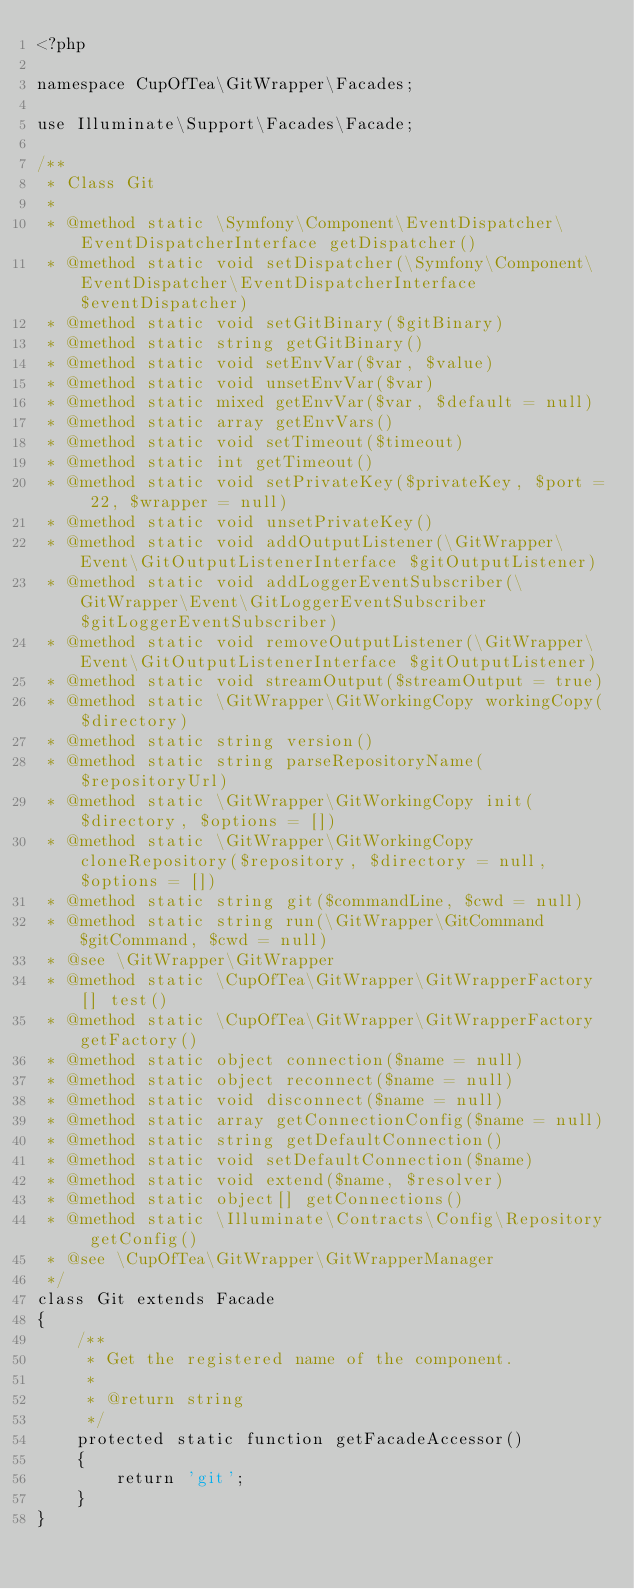Convert code to text. <code><loc_0><loc_0><loc_500><loc_500><_PHP_><?php

namespace CupOfTea\GitWrapper\Facades;

use Illuminate\Support\Facades\Facade;

/**
 * Class Git
 *
 * @method static \Symfony\Component\EventDispatcher\EventDispatcherInterface getDispatcher()
 * @method static void setDispatcher(\Symfony\Component\EventDispatcher\EventDispatcherInterface $eventDispatcher)
 * @method static void setGitBinary($gitBinary)
 * @method static string getGitBinary()
 * @method static void setEnvVar($var, $value)
 * @method static void unsetEnvVar($var)
 * @method static mixed getEnvVar($var, $default = null)
 * @method static array getEnvVars()
 * @method static void setTimeout($timeout)
 * @method static int getTimeout()
 * @method static void setPrivateKey($privateKey, $port = 22, $wrapper = null)
 * @method static void unsetPrivateKey()
 * @method static void addOutputListener(\GitWrapper\Event\GitOutputListenerInterface $gitOutputListener)
 * @method static void addLoggerEventSubscriber(\GitWrapper\Event\GitLoggerEventSubscriber $gitLoggerEventSubscriber)
 * @method static void removeOutputListener(\GitWrapper\Event\GitOutputListenerInterface $gitOutputListener)
 * @method static void streamOutput($streamOutput = true)
 * @method static \GitWrapper\GitWorkingCopy workingCopy($directory)
 * @method static string version()
 * @method static string parseRepositoryName($repositoryUrl)
 * @method static \GitWrapper\GitWorkingCopy init($directory, $options = [])
 * @method static \GitWrapper\GitWorkingCopy cloneRepository($repository, $directory = null, $options = [])
 * @method static string git($commandLine, $cwd = null)
 * @method static string run(\GitWrapper\GitCommand $gitCommand, $cwd = null)
 * @see \GitWrapper\GitWrapper
 * @method static \CupOfTea\GitWrapper\GitWrapperFactory[] test()
 * @method static \CupOfTea\GitWrapper\GitWrapperFactory getFactory()
 * @method static object connection($name = null)
 * @method static object reconnect($name = null)
 * @method static void disconnect($name = null)
 * @method static array getConnectionConfig($name = null)
 * @method static string getDefaultConnection()
 * @method static void setDefaultConnection($name)
 * @method static void extend($name, $resolver)
 * @method static object[] getConnections()
 * @method static \Illuminate\Contracts\Config\Repository getConfig()
 * @see \CupOfTea\GitWrapper\GitWrapperManager
 */
class Git extends Facade
{
    /**
     * Get the registered name of the component.
     *
     * @return string
     */
    protected static function getFacadeAccessor()
    {
        return 'git';
    }
}
</code> 